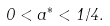Convert formula to latex. <formula><loc_0><loc_0><loc_500><loc_500>0 < a ^ { * } < 1 / 4 .</formula> 